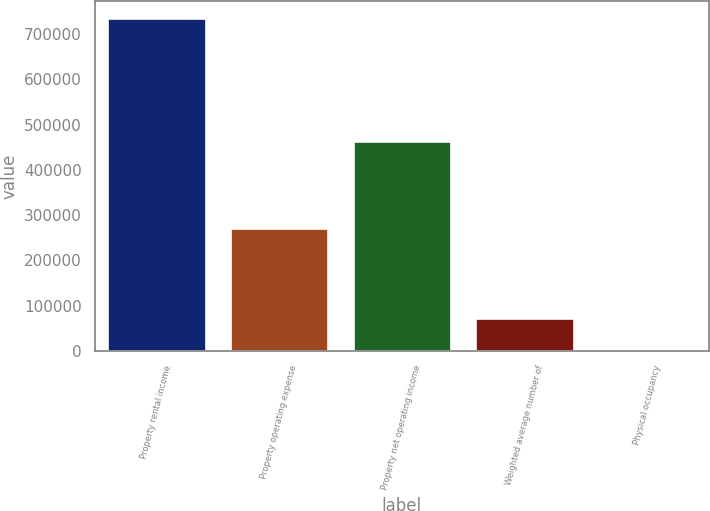<chart> <loc_0><loc_0><loc_500><loc_500><bar_chart><fcel>Property rental income<fcel>Property operating expense<fcel>Property net operating income<fcel>Weighted average number of<fcel>Physical occupancy<nl><fcel>736329<fcel>271297<fcel>465032<fcel>73731<fcel>94.3<nl></chart> 